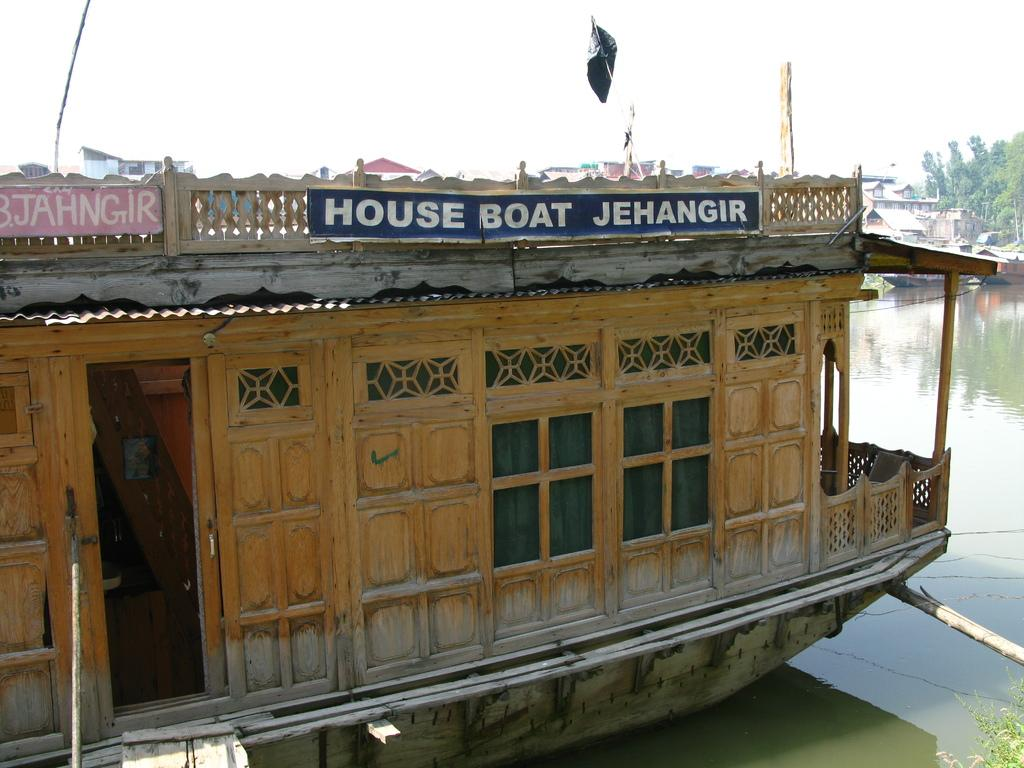What is the main subject of the image? The main subject of the image is a boat. Where is the boat located? The boat is on the water. What can be seen in the background of the image? There are trees, sky, and plants visible in the background of the image. What team is responsible for maintaining the boat in the image? There is no information about a team responsible for maintaining the boat in the image. What type of nose can be seen on the boat in the image? There is no nose present on the boat in the image. 